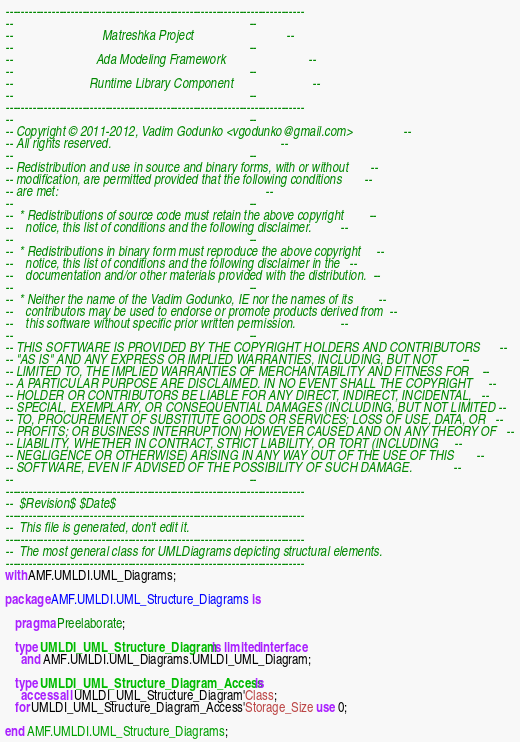Convert code to text. <code><loc_0><loc_0><loc_500><loc_500><_Ada_>------------------------------------------------------------------------------
--                                                                          --
--                            Matreshka Project                             --
--                                                                          --
--                          Ada Modeling Framework                          --
--                                                                          --
--                        Runtime Library Component                         --
--                                                                          --
------------------------------------------------------------------------------
--                                                                          --
-- Copyright © 2011-2012, Vadim Godunko <vgodunko@gmail.com>                --
-- All rights reserved.                                                     --
--                                                                          --
-- Redistribution and use in source and binary forms, with or without       --
-- modification, are permitted provided that the following conditions       --
-- are met:                                                                 --
--                                                                          --
--  * Redistributions of source code must retain the above copyright        --
--    notice, this list of conditions and the following disclaimer.         --
--                                                                          --
--  * Redistributions in binary form must reproduce the above copyright     --
--    notice, this list of conditions and the following disclaimer in the   --
--    documentation and/or other materials provided with the distribution.  --
--                                                                          --
--  * Neither the name of the Vadim Godunko, IE nor the names of its        --
--    contributors may be used to endorse or promote products derived from  --
--    this software without specific prior written permission.              --
--                                                                          --
-- THIS SOFTWARE IS PROVIDED BY THE COPYRIGHT HOLDERS AND CONTRIBUTORS      --
-- "AS IS" AND ANY EXPRESS OR IMPLIED WARRANTIES, INCLUDING, BUT NOT        --
-- LIMITED TO, THE IMPLIED WARRANTIES OF MERCHANTABILITY AND FITNESS FOR    --
-- A PARTICULAR PURPOSE ARE DISCLAIMED. IN NO EVENT SHALL THE COPYRIGHT     --
-- HOLDER OR CONTRIBUTORS BE LIABLE FOR ANY DIRECT, INDIRECT, INCIDENTAL,   --
-- SPECIAL, EXEMPLARY, OR CONSEQUENTIAL DAMAGES (INCLUDING, BUT NOT LIMITED --
-- TO, PROCUREMENT OF SUBSTITUTE GOODS OR SERVICES; LOSS OF USE, DATA, OR   --
-- PROFITS; OR BUSINESS INTERRUPTION) HOWEVER CAUSED AND ON ANY THEORY OF   --
-- LIABILITY, WHETHER IN CONTRACT, STRICT LIABILITY, OR TORT (INCLUDING     --
-- NEGLIGENCE OR OTHERWISE) ARISING IN ANY WAY OUT OF THE USE OF THIS       --
-- SOFTWARE, EVEN IF ADVISED OF THE POSSIBILITY OF SUCH DAMAGE.             --
--                                                                          --
------------------------------------------------------------------------------
--  $Revision$ $Date$
------------------------------------------------------------------------------
--  This file is generated, don't edit it.
------------------------------------------------------------------------------
--  The most general class for UMLDiagrams depicting structural elements.
------------------------------------------------------------------------------
with AMF.UMLDI.UML_Diagrams;

package AMF.UMLDI.UML_Structure_Diagrams is

   pragma Preelaborate;

   type UMLDI_UML_Structure_Diagram is limited interface
     and AMF.UMLDI.UML_Diagrams.UMLDI_UML_Diagram;

   type UMLDI_UML_Structure_Diagram_Access is
     access all UMLDI_UML_Structure_Diagram'Class;
   for UMLDI_UML_Structure_Diagram_Access'Storage_Size use 0;

end AMF.UMLDI.UML_Structure_Diagrams;
</code> 